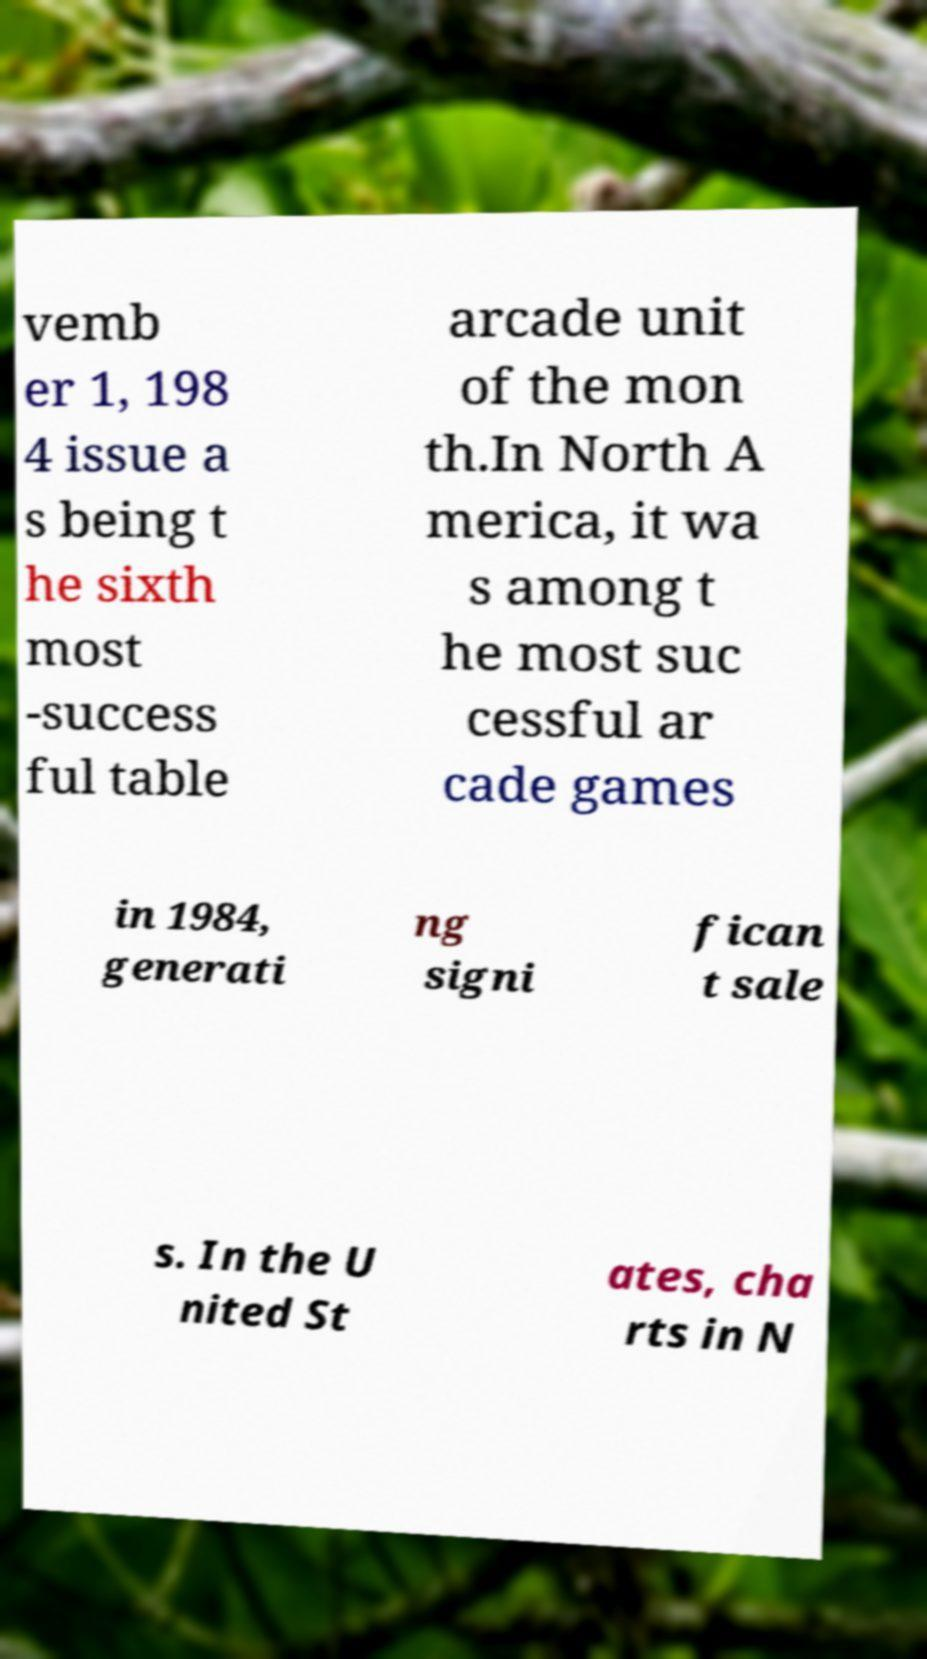Please read and relay the text visible in this image. What does it say? vemb er 1, 198 4 issue a s being t he sixth most -success ful table arcade unit of the mon th.In North A merica, it wa s among t he most suc cessful ar cade games in 1984, generati ng signi fican t sale s. In the U nited St ates, cha rts in N 